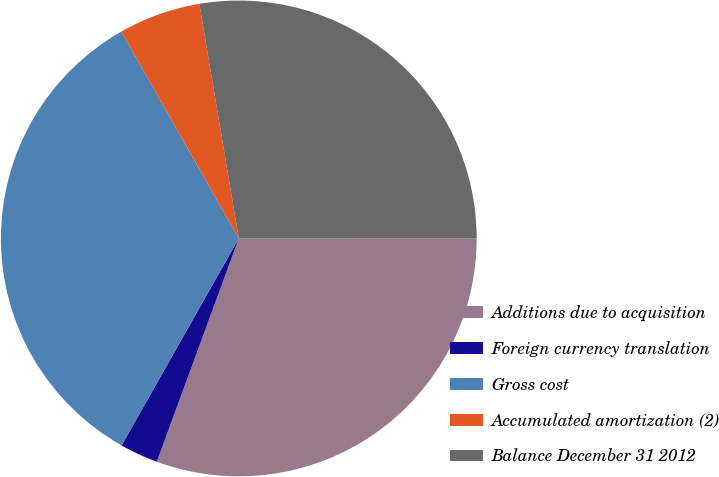<chart> <loc_0><loc_0><loc_500><loc_500><pie_chart><fcel>Additions due to acquisition<fcel>Foreign currency translation<fcel>Gross cost<fcel>Accumulated amortization (2)<fcel>Balance December 31 2012<nl><fcel>30.61%<fcel>2.6%<fcel>33.58%<fcel>5.57%<fcel>27.64%<nl></chart> 